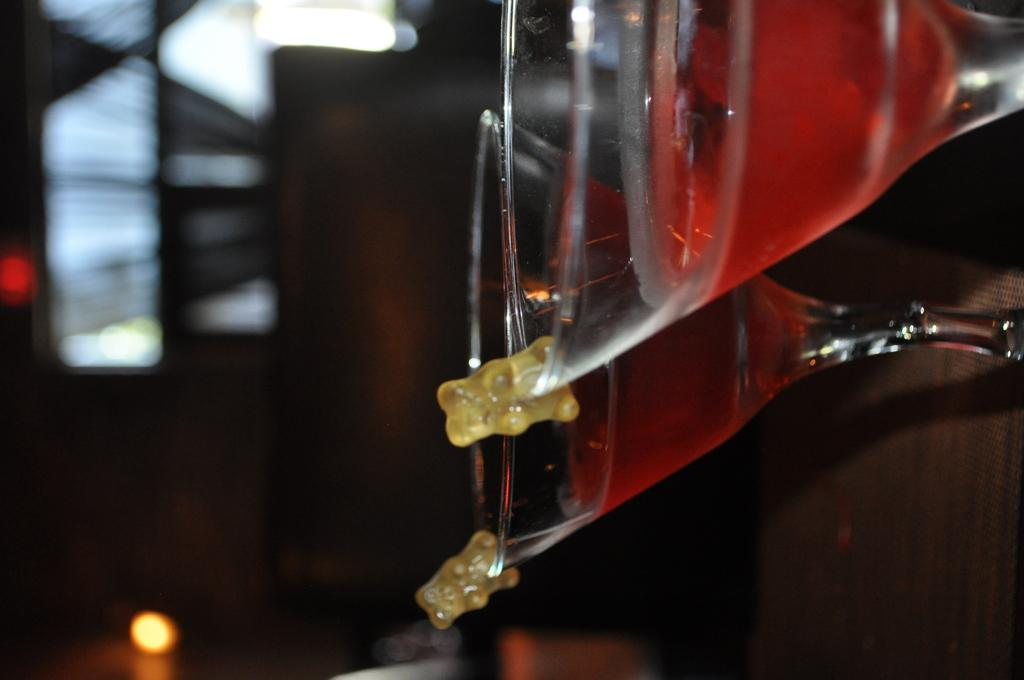What can be seen in the image that contains a liquid? There are two glasses with a drink in the image. Where are the glasses placed? The glasses are on a platform. Can you describe the background of the image? The background of the image is blurred. How many horses are visible in the image? There are no horses present in the image. What type of engine can be seen powering the glasses in the image? There is no engine present in the image, and the glasses are not powered by any engine. 